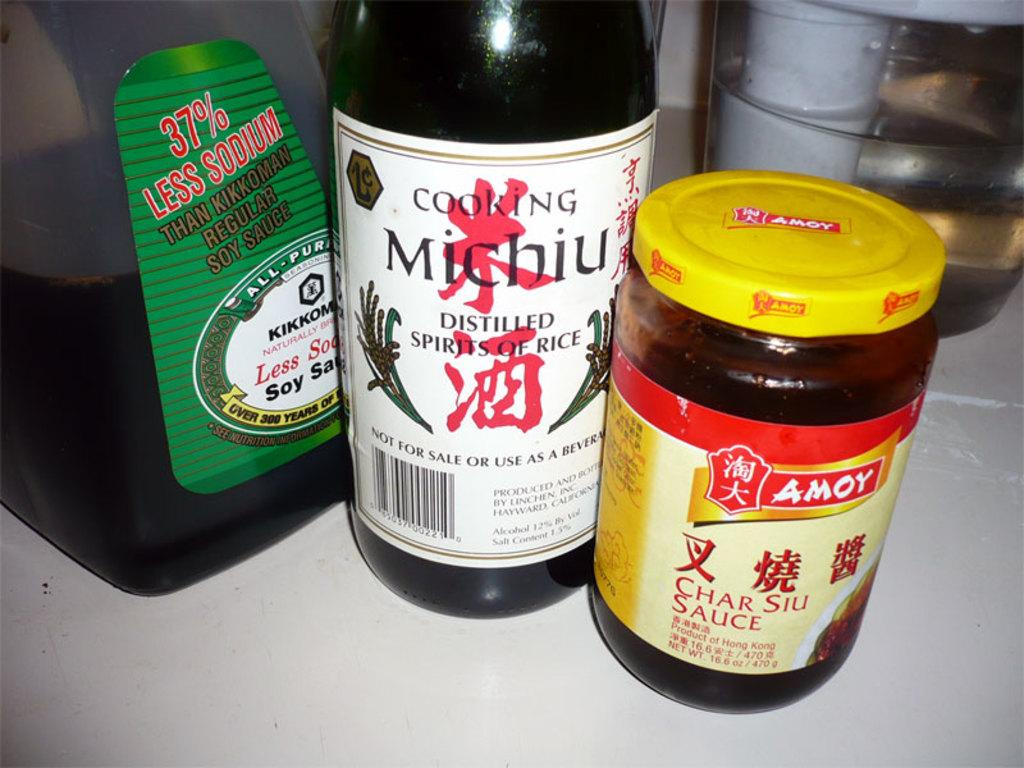<image>
Render a clear and concise summary of the photo. A bottle of Less Sodium Kikkoman soy sauce, a bottle of cooking Michiu, and a bottle of AMOY Char Siu Sauce. 